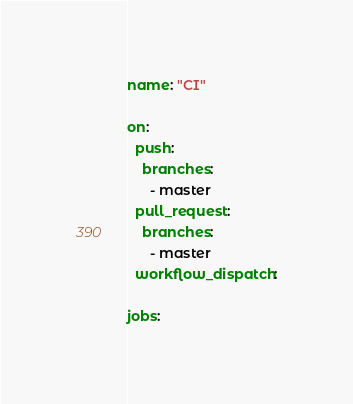Convert code to text. <code><loc_0><loc_0><loc_500><loc_500><_YAML_>name: "CI"

on:
  push:
    branches:
      - master
  pull_request:
    branches:
      - master
  workflow_dispatch:

jobs:</code> 